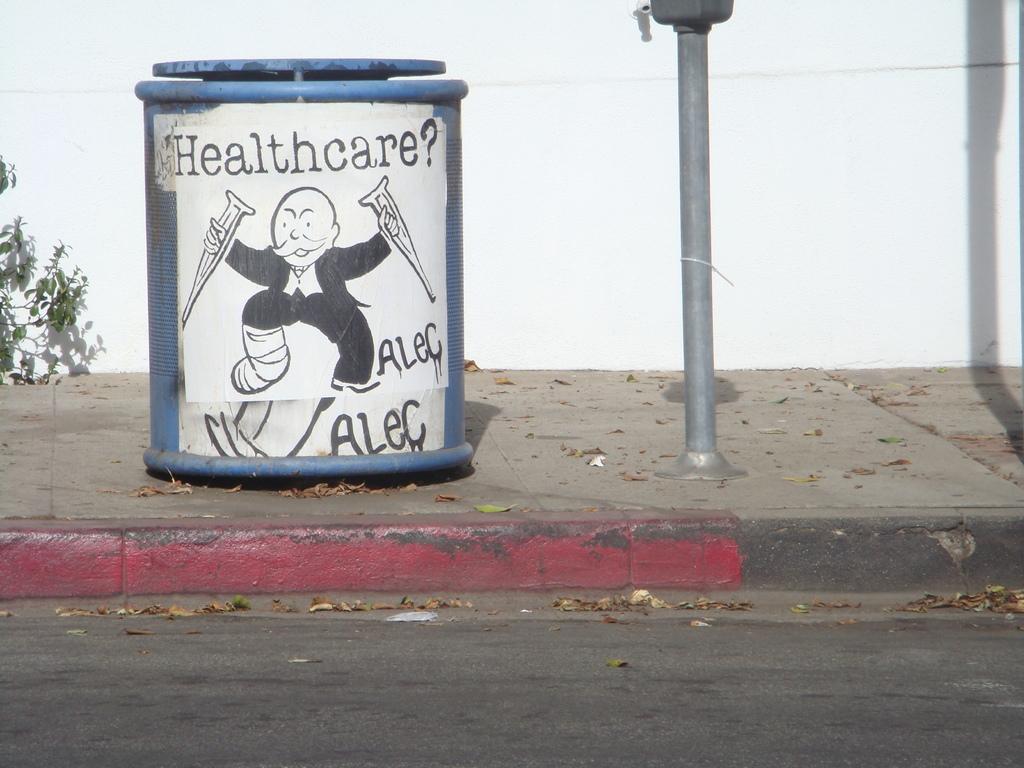Why is this little guy angry?
Give a very brief answer. Healthcare. What does the guy hold in his hands?
Your answer should be compact. Answering does not require reading text in the image. 